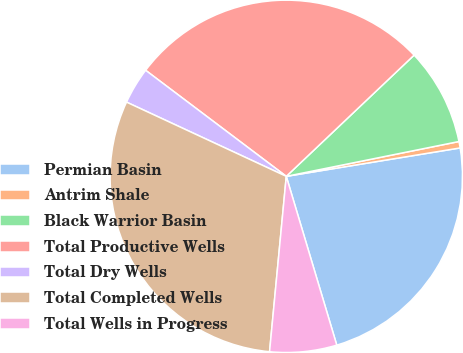Convert chart to OTSL. <chart><loc_0><loc_0><loc_500><loc_500><pie_chart><fcel>Permian Basin<fcel>Antrim Shale<fcel>Black Warrior Basin<fcel>Total Productive Wells<fcel>Total Dry Wells<fcel>Total Completed Wells<fcel>Total Wells in Progress<nl><fcel>22.95%<fcel>0.59%<fcel>8.91%<fcel>27.64%<fcel>3.36%<fcel>30.41%<fcel>6.14%<nl></chart> 